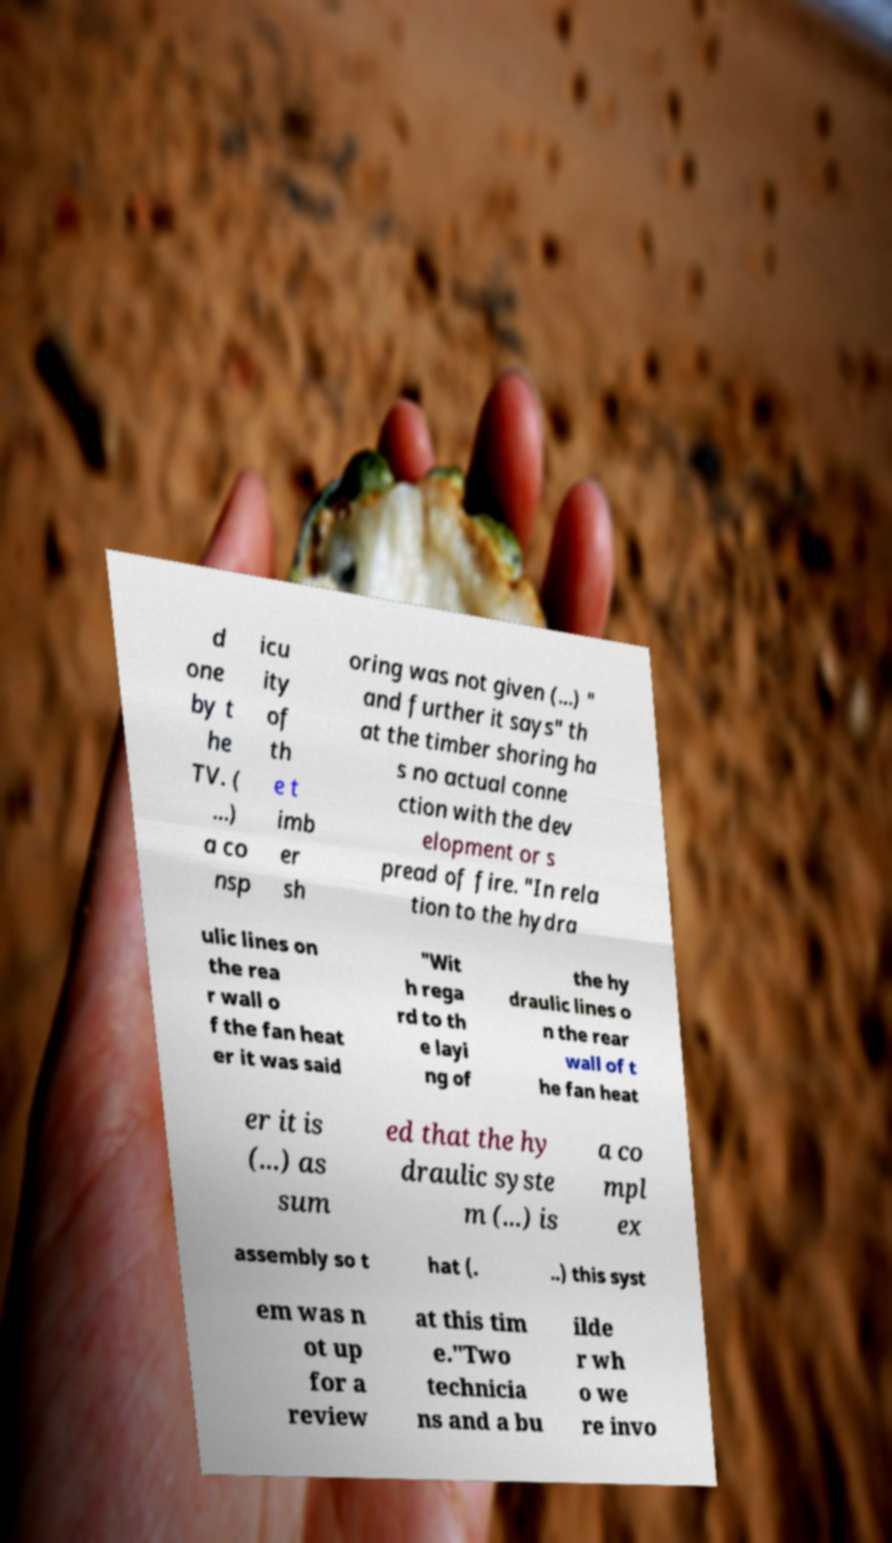Can you accurately transcribe the text from the provided image for me? d one by t he TV. ( ...) a co nsp icu ity of th e t imb er sh oring was not given (...) " and further it says" th at the timber shoring ha s no actual conne ction with the dev elopment or s pread of fire. "In rela tion to the hydra ulic lines on the rea r wall o f the fan heat er it was said "Wit h rega rd to th e layi ng of the hy draulic lines o n the rear wall of t he fan heat er it is (...) as sum ed that the hy draulic syste m (...) is a co mpl ex assembly so t hat (. ..) this syst em was n ot up for a review at this tim e."Two technicia ns and a bu ilde r wh o we re invo 